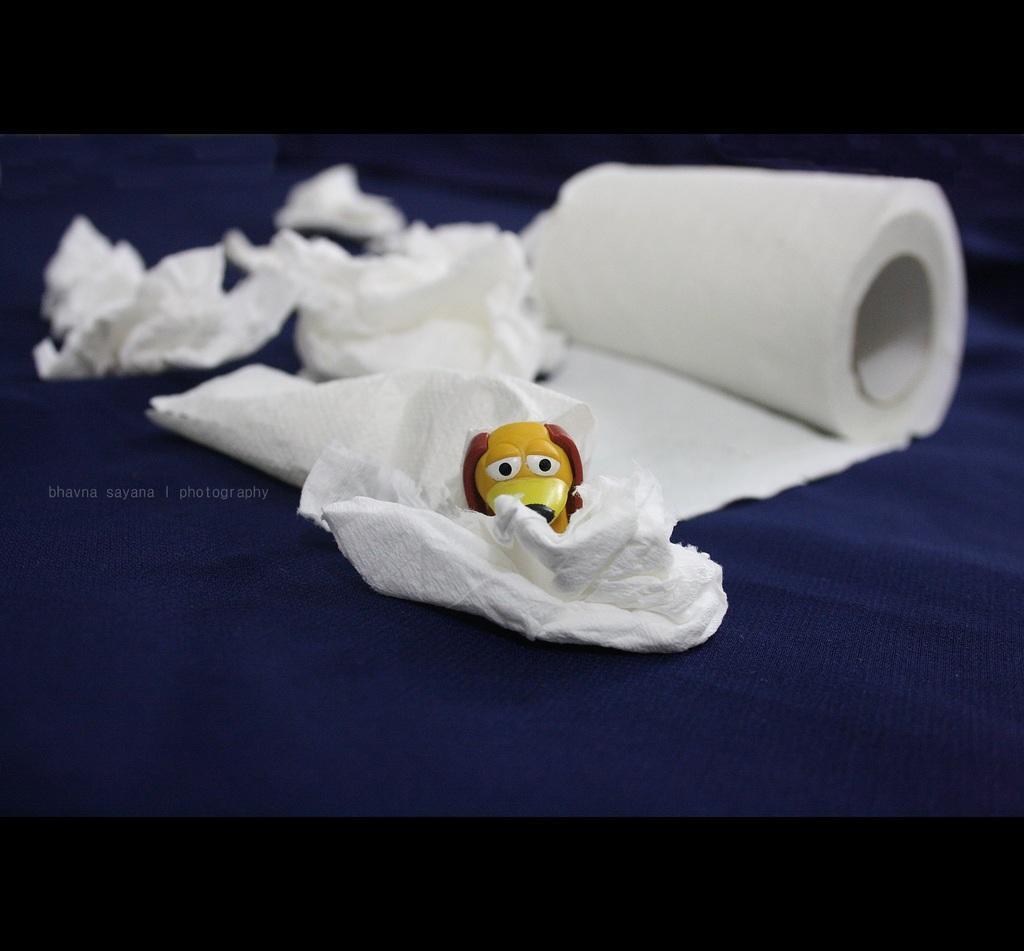Please provide a concise description of this image. In this image I can see the blue colored surface and on it I can see a tissue roll which is white in color. On the tissue paper I can see a toy which is yellow, brown, black and white in color which is in the shape of a animal. 